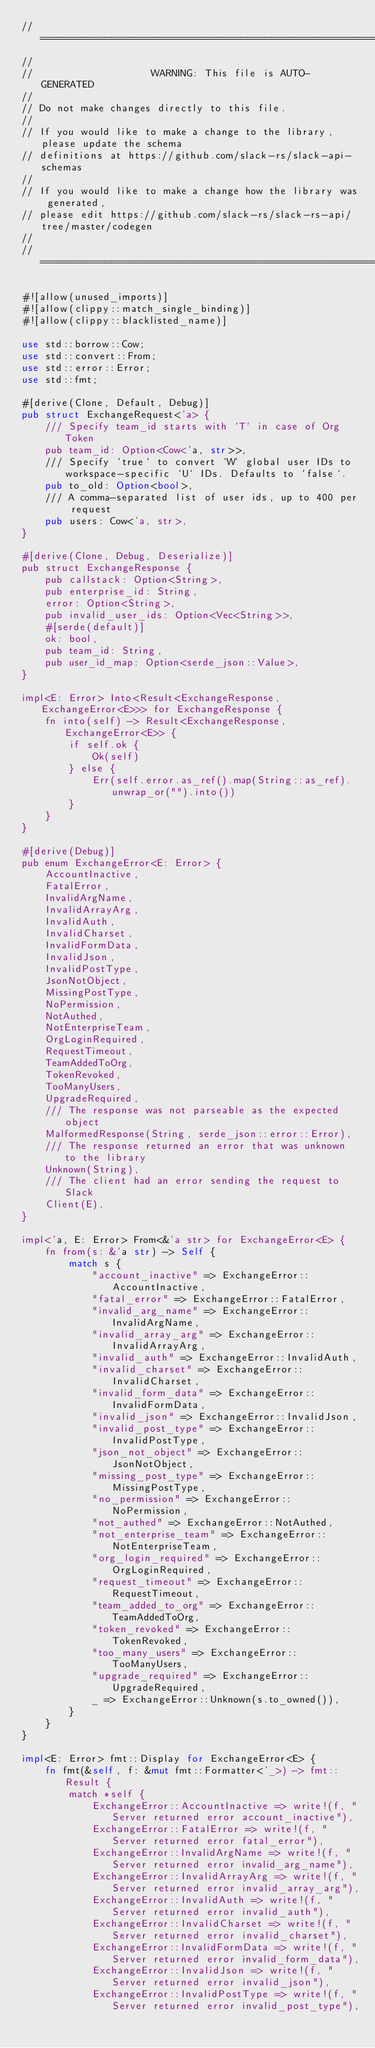Convert code to text. <code><loc_0><loc_0><loc_500><loc_500><_Rust_>//=============================================================================
//
//                    WARNING: This file is AUTO-GENERATED
//
// Do not make changes directly to this file.
//
// If you would like to make a change to the library, please update the schema
// definitions at https://github.com/slack-rs/slack-api-schemas
//
// If you would like to make a change how the library was generated,
// please edit https://github.com/slack-rs/slack-rs-api/tree/master/codegen
//
//=============================================================================

#![allow(unused_imports)]
#![allow(clippy::match_single_binding)]
#![allow(clippy::blacklisted_name)]

use std::borrow::Cow;
use std::convert::From;
use std::error::Error;
use std::fmt;

#[derive(Clone, Default, Debug)]
pub struct ExchangeRequest<'a> {
    /// Specify team_id starts with `T` in case of Org Token
    pub team_id: Option<Cow<'a, str>>,
    /// Specify `true` to convert `W` global user IDs to workspace-specific `U` IDs. Defaults to `false`.
    pub to_old: Option<bool>,
    /// A comma-separated list of user ids, up to 400 per request
    pub users: Cow<'a, str>,
}

#[derive(Clone, Debug, Deserialize)]
pub struct ExchangeResponse {
    pub callstack: Option<String>,
    pub enterprise_id: String,
    error: Option<String>,
    pub invalid_user_ids: Option<Vec<String>>,
    #[serde(default)]
    ok: bool,
    pub team_id: String,
    pub user_id_map: Option<serde_json::Value>,
}

impl<E: Error> Into<Result<ExchangeResponse, ExchangeError<E>>> for ExchangeResponse {
    fn into(self) -> Result<ExchangeResponse, ExchangeError<E>> {
        if self.ok {
            Ok(self)
        } else {
            Err(self.error.as_ref().map(String::as_ref).unwrap_or("").into())
        }
    }
}

#[derive(Debug)]
pub enum ExchangeError<E: Error> {
    AccountInactive,
    FatalError,
    InvalidArgName,
    InvalidArrayArg,
    InvalidAuth,
    InvalidCharset,
    InvalidFormData,
    InvalidJson,
    InvalidPostType,
    JsonNotObject,
    MissingPostType,
    NoPermission,
    NotAuthed,
    NotEnterpriseTeam,
    OrgLoginRequired,
    RequestTimeout,
    TeamAddedToOrg,
    TokenRevoked,
    TooManyUsers,
    UpgradeRequired,
    /// The response was not parseable as the expected object
    MalformedResponse(String, serde_json::error::Error),
    /// The response returned an error that was unknown to the library
    Unknown(String),
    /// The client had an error sending the request to Slack
    Client(E),
}

impl<'a, E: Error> From<&'a str> for ExchangeError<E> {
    fn from(s: &'a str) -> Self {
        match s {
            "account_inactive" => ExchangeError::AccountInactive,
            "fatal_error" => ExchangeError::FatalError,
            "invalid_arg_name" => ExchangeError::InvalidArgName,
            "invalid_array_arg" => ExchangeError::InvalidArrayArg,
            "invalid_auth" => ExchangeError::InvalidAuth,
            "invalid_charset" => ExchangeError::InvalidCharset,
            "invalid_form_data" => ExchangeError::InvalidFormData,
            "invalid_json" => ExchangeError::InvalidJson,
            "invalid_post_type" => ExchangeError::InvalidPostType,
            "json_not_object" => ExchangeError::JsonNotObject,
            "missing_post_type" => ExchangeError::MissingPostType,
            "no_permission" => ExchangeError::NoPermission,
            "not_authed" => ExchangeError::NotAuthed,
            "not_enterprise_team" => ExchangeError::NotEnterpriseTeam,
            "org_login_required" => ExchangeError::OrgLoginRequired,
            "request_timeout" => ExchangeError::RequestTimeout,
            "team_added_to_org" => ExchangeError::TeamAddedToOrg,
            "token_revoked" => ExchangeError::TokenRevoked,
            "too_many_users" => ExchangeError::TooManyUsers,
            "upgrade_required" => ExchangeError::UpgradeRequired,
            _ => ExchangeError::Unknown(s.to_owned()),
        }
    }
}

impl<E: Error> fmt::Display for ExchangeError<E> {
    fn fmt(&self, f: &mut fmt::Formatter<'_>) -> fmt::Result {
        match *self {
            ExchangeError::AccountInactive => write!(f, "Server returned error account_inactive"),
            ExchangeError::FatalError => write!(f, "Server returned error fatal_error"),
            ExchangeError::InvalidArgName => write!(f, "Server returned error invalid_arg_name"),
            ExchangeError::InvalidArrayArg => write!(f, "Server returned error invalid_array_arg"),
            ExchangeError::InvalidAuth => write!(f, "Server returned error invalid_auth"),
            ExchangeError::InvalidCharset => write!(f, "Server returned error invalid_charset"),
            ExchangeError::InvalidFormData => write!(f, "Server returned error invalid_form_data"),
            ExchangeError::InvalidJson => write!(f, "Server returned error invalid_json"),
            ExchangeError::InvalidPostType => write!(f, "Server returned error invalid_post_type"),</code> 